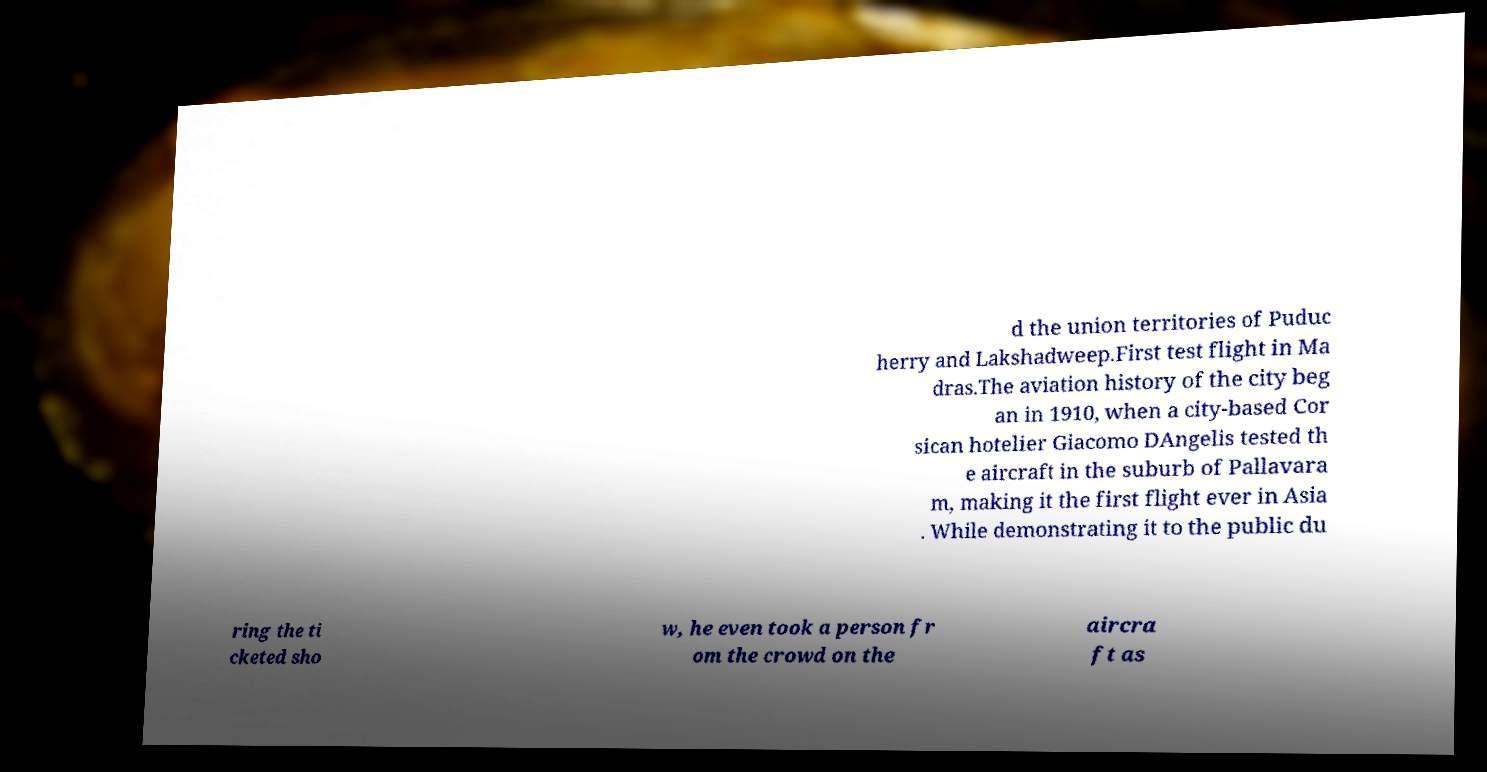Please read and relay the text visible in this image. What does it say? d the union territories of Puduc herry and Lakshadweep.First test flight in Ma dras.The aviation history of the city beg an in 1910, when a city-based Cor sican hotelier Giacomo DAngelis tested th e aircraft in the suburb of Pallavara m, making it the first flight ever in Asia . While demonstrating it to the public du ring the ti cketed sho w, he even took a person fr om the crowd on the aircra ft as 